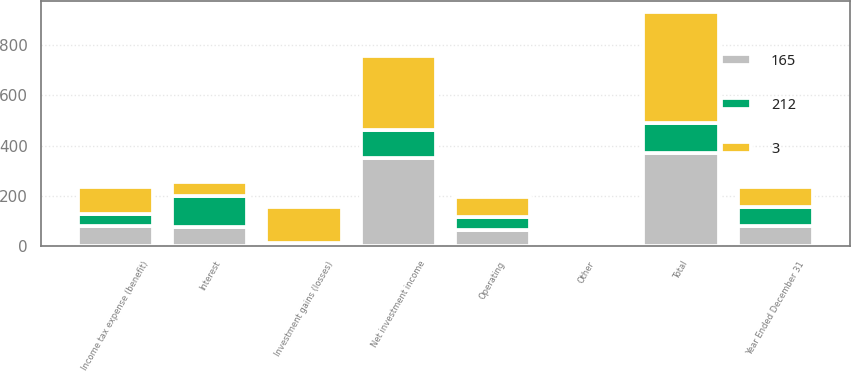Convert chart. <chart><loc_0><loc_0><loc_500><loc_500><stacked_bar_chart><ecel><fcel>Year Ended December 31<fcel>Net investment income<fcel>Investment gains (losses)<fcel>Other<fcel>Total<fcel>Operating<fcel>Interest<fcel>Income tax expense (benefit)<nl><fcel>3<fcel>79<fcel>295<fcel>144<fcel>2<fcel>441<fcel>79<fcel>55<fcel>108<nl><fcel>165<fcel>79<fcel>351<fcel>10<fcel>10<fcel>371<fcel>65<fcel>75<fcel>81<nl><fcel>212<fcel>79<fcel>109<fcel>3<fcel>11<fcel>117<fcel>52<fcel>126<fcel>46<nl></chart> 